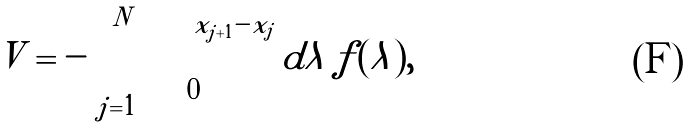Convert formula to latex. <formula><loc_0><loc_0><loc_500><loc_500>V = - \sum _ { j = 1 } ^ { N } \int _ { 0 } ^ { x _ { j + 1 } - x _ { j } } d \lambda \, f ( \lambda ) ,</formula> 